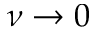Convert formula to latex. <formula><loc_0><loc_0><loc_500><loc_500>\nu \rightarrow 0</formula> 